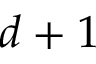Convert formula to latex. <formula><loc_0><loc_0><loc_500><loc_500>d + 1</formula> 